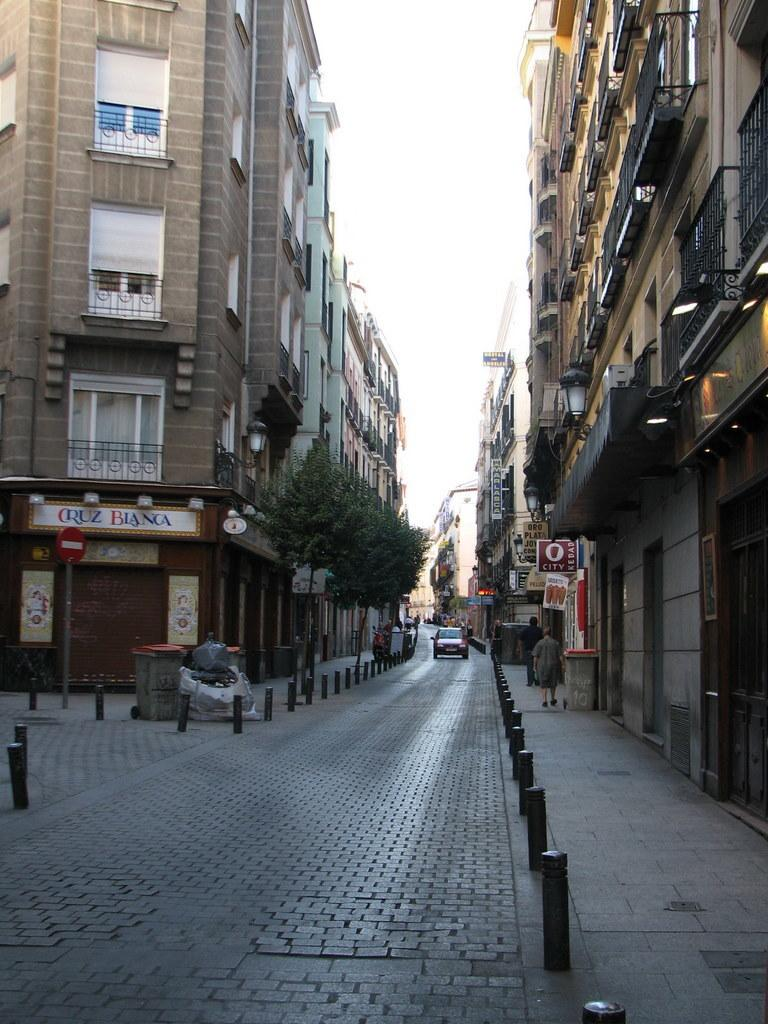What type of container is present in the image? There is a bin in the image. What mode of transportation can be seen in the image? There is a vehicle in the image. Are there any human figures in the image? Yes, there are people in the image. What type of informational or directional displays are present in the image? There are sign boards in the image. What type of natural vegetation is present in the image? There are trees in the image. What type of flat, rectangular objects are present in the image? There are boards in the image. What type of man-made structures are present in the image? There are buildings in the image. What type of long, thin metal objects are present in the image? There are rods in the image. What part of the natural environment is visible in the image? The sky is visible in the image. Where are the lights attached in the image? The lights are attached to a wall in the image. What type of relation can be seen between the substance and the spot in the image? There is no substance or spot mentioned in the image, so this question cannot be answered. 